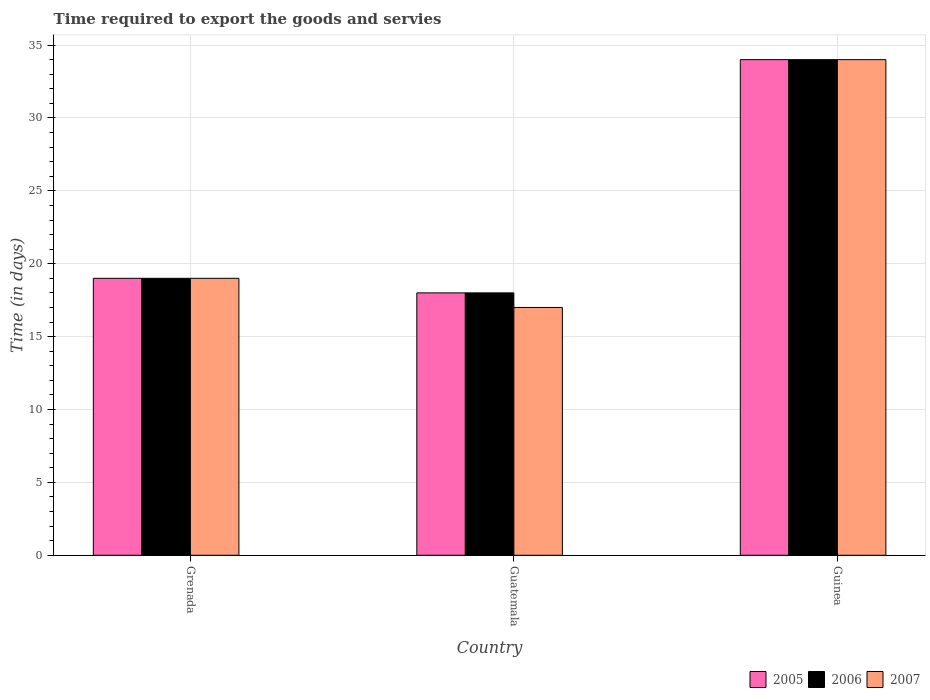Are the number of bars per tick equal to the number of legend labels?
Ensure brevity in your answer.  Yes. Are the number of bars on each tick of the X-axis equal?
Make the answer very short. Yes. How many bars are there on the 2nd tick from the left?
Your response must be concise. 3. How many bars are there on the 2nd tick from the right?
Offer a terse response. 3. What is the label of the 1st group of bars from the left?
Your response must be concise. Grenada. Across all countries, what is the maximum number of days required to export the goods and services in 2006?
Your response must be concise. 34. Across all countries, what is the minimum number of days required to export the goods and services in 2005?
Your answer should be very brief. 18. In which country was the number of days required to export the goods and services in 2007 maximum?
Give a very brief answer. Guinea. In which country was the number of days required to export the goods and services in 2006 minimum?
Your response must be concise. Guatemala. What is the total number of days required to export the goods and services in 2006 in the graph?
Provide a short and direct response. 71. What is the difference between the number of days required to export the goods and services in 2007 in Guinea and the number of days required to export the goods and services in 2006 in Grenada?
Provide a short and direct response. 15. What is the average number of days required to export the goods and services in 2007 per country?
Your answer should be compact. 23.33. In how many countries, is the number of days required to export the goods and services in 2005 greater than 26 days?
Offer a terse response. 1. What is the ratio of the number of days required to export the goods and services in 2005 in Guatemala to that in Guinea?
Offer a very short reply. 0.53. Is the number of days required to export the goods and services in 2005 in Grenada less than that in Guatemala?
Offer a very short reply. No. Is the difference between the number of days required to export the goods and services in 2006 in Grenada and Guatemala greater than the difference between the number of days required to export the goods and services in 2007 in Grenada and Guatemala?
Provide a short and direct response. No. What is the difference between the highest and the lowest number of days required to export the goods and services in 2005?
Keep it short and to the point. 16. What does the 1st bar from the left in Guatemala represents?
Your answer should be very brief. 2005. What does the 1st bar from the right in Guatemala represents?
Provide a succinct answer. 2007. Is it the case that in every country, the sum of the number of days required to export the goods and services in 2007 and number of days required to export the goods and services in 2006 is greater than the number of days required to export the goods and services in 2005?
Make the answer very short. Yes. How many bars are there?
Offer a terse response. 9. How are the legend labels stacked?
Provide a succinct answer. Horizontal. What is the title of the graph?
Your answer should be very brief. Time required to export the goods and servies. Does "1986" appear as one of the legend labels in the graph?
Offer a very short reply. No. What is the label or title of the Y-axis?
Provide a succinct answer. Time (in days). What is the Time (in days) of 2005 in Grenada?
Your answer should be very brief. 19. What is the Time (in days) in 2006 in Guatemala?
Your response must be concise. 18. What is the Time (in days) in 2007 in Guatemala?
Offer a very short reply. 17. Across all countries, what is the maximum Time (in days) in 2006?
Provide a short and direct response. 34. Across all countries, what is the maximum Time (in days) in 2007?
Ensure brevity in your answer.  34. Across all countries, what is the minimum Time (in days) of 2005?
Your answer should be very brief. 18. Across all countries, what is the minimum Time (in days) of 2006?
Your answer should be very brief. 18. Across all countries, what is the minimum Time (in days) of 2007?
Provide a short and direct response. 17. What is the total Time (in days) in 2005 in the graph?
Make the answer very short. 71. What is the total Time (in days) in 2006 in the graph?
Give a very brief answer. 71. What is the total Time (in days) of 2007 in the graph?
Provide a succinct answer. 70. What is the difference between the Time (in days) of 2006 in Grenada and that in Guatemala?
Provide a short and direct response. 1. What is the difference between the Time (in days) in 2007 in Grenada and that in Guatemala?
Offer a terse response. 2. What is the difference between the Time (in days) in 2005 in Grenada and that in Guinea?
Offer a terse response. -15. What is the difference between the Time (in days) of 2007 in Grenada and that in Guinea?
Give a very brief answer. -15. What is the difference between the Time (in days) of 2005 in Grenada and the Time (in days) of 2007 in Guatemala?
Your answer should be compact. 2. What is the difference between the Time (in days) in 2006 in Grenada and the Time (in days) in 2007 in Guatemala?
Provide a short and direct response. 2. What is the difference between the Time (in days) in 2005 in Grenada and the Time (in days) in 2006 in Guinea?
Make the answer very short. -15. What is the difference between the Time (in days) of 2005 in Grenada and the Time (in days) of 2007 in Guinea?
Offer a very short reply. -15. What is the difference between the Time (in days) in 2006 in Grenada and the Time (in days) in 2007 in Guinea?
Give a very brief answer. -15. What is the difference between the Time (in days) of 2006 in Guatemala and the Time (in days) of 2007 in Guinea?
Give a very brief answer. -16. What is the average Time (in days) in 2005 per country?
Ensure brevity in your answer.  23.67. What is the average Time (in days) in 2006 per country?
Provide a short and direct response. 23.67. What is the average Time (in days) in 2007 per country?
Your answer should be compact. 23.33. What is the difference between the Time (in days) in 2006 and Time (in days) in 2007 in Guatemala?
Provide a short and direct response. 1. What is the difference between the Time (in days) in 2005 and Time (in days) in 2006 in Guinea?
Offer a terse response. 0. What is the difference between the Time (in days) in 2006 and Time (in days) in 2007 in Guinea?
Your response must be concise. 0. What is the ratio of the Time (in days) of 2005 in Grenada to that in Guatemala?
Provide a succinct answer. 1.06. What is the ratio of the Time (in days) in 2006 in Grenada to that in Guatemala?
Make the answer very short. 1.06. What is the ratio of the Time (in days) of 2007 in Grenada to that in Guatemala?
Provide a short and direct response. 1.12. What is the ratio of the Time (in days) of 2005 in Grenada to that in Guinea?
Provide a succinct answer. 0.56. What is the ratio of the Time (in days) of 2006 in Grenada to that in Guinea?
Give a very brief answer. 0.56. What is the ratio of the Time (in days) in 2007 in Grenada to that in Guinea?
Offer a very short reply. 0.56. What is the ratio of the Time (in days) of 2005 in Guatemala to that in Guinea?
Your response must be concise. 0.53. What is the ratio of the Time (in days) of 2006 in Guatemala to that in Guinea?
Your response must be concise. 0.53. What is the difference between the highest and the second highest Time (in days) of 2006?
Your answer should be very brief. 15. What is the difference between the highest and the lowest Time (in days) of 2005?
Provide a short and direct response. 16. 